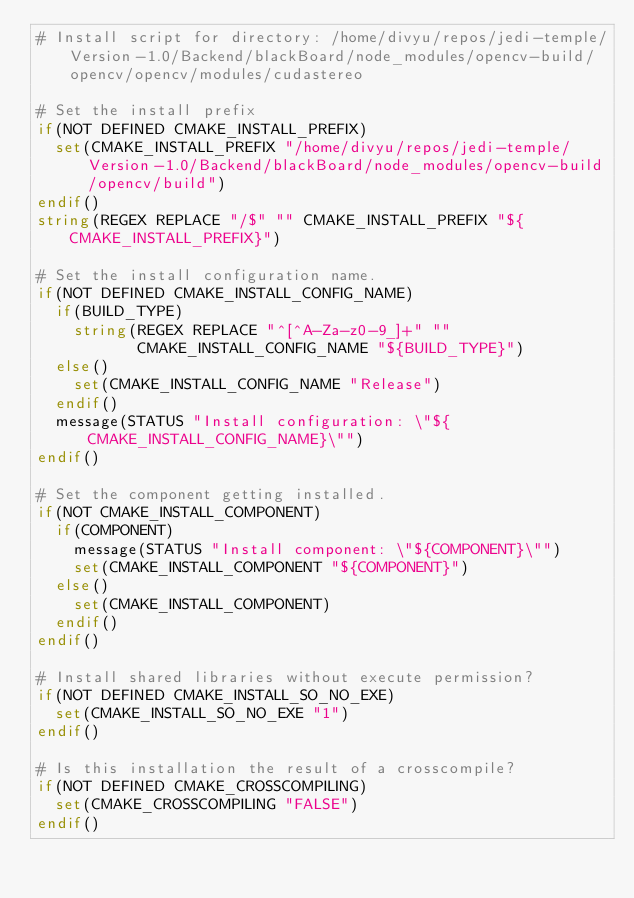<code> <loc_0><loc_0><loc_500><loc_500><_CMake_># Install script for directory: /home/divyu/repos/jedi-temple/Version-1.0/Backend/blackBoard/node_modules/opencv-build/opencv/opencv/modules/cudastereo

# Set the install prefix
if(NOT DEFINED CMAKE_INSTALL_PREFIX)
  set(CMAKE_INSTALL_PREFIX "/home/divyu/repos/jedi-temple/Version-1.0/Backend/blackBoard/node_modules/opencv-build/opencv/build")
endif()
string(REGEX REPLACE "/$" "" CMAKE_INSTALL_PREFIX "${CMAKE_INSTALL_PREFIX}")

# Set the install configuration name.
if(NOT DEFINED CMAKE_INSTALL_CONFIG_NAME)
  if(BUILD_TYPE)
    string(REGEX REPLACE "^[^A-Za-z0-9_]+" ""
           CMAKE_INSTALL_CONFIG_NAME "${BUILD_TYPE}")
  else()
    set(CMAKE_INSTALL_CONFIG_NAME "Release")
  endif()
  message(STATUS "Install configuration: \"${CMAKE_INSTALL_CONFIG_NAME}\"")
endif()

# Set the component getting installed.
if(NOT CMAKE_INSTALL_COMPONENT)
  if(COMPONENT)
    message(STATUS "Install component: \"${COMPONENT}\"")
    set(CMAKE_INSTALL_COMPONENT "${COMPONENT}")
  else()
    set(CMAKE_INSTALL_COMPONENT)
  endif()
endif()

# Install shared libraries without execute permission?
if(NOT DEFINED CMAKE_INSTALL_SO_NO_EXE)
  set(CMAKE_INSTALL_SO_NO_EXE "1")
endif()

# Is this installation the result of a crosscompile?
if(NOT DEFINED CMAKE_CROSSCOMPILING)
  set(CMAKE_CROSSCOMPILING "FALSE")
endif()

</code> 